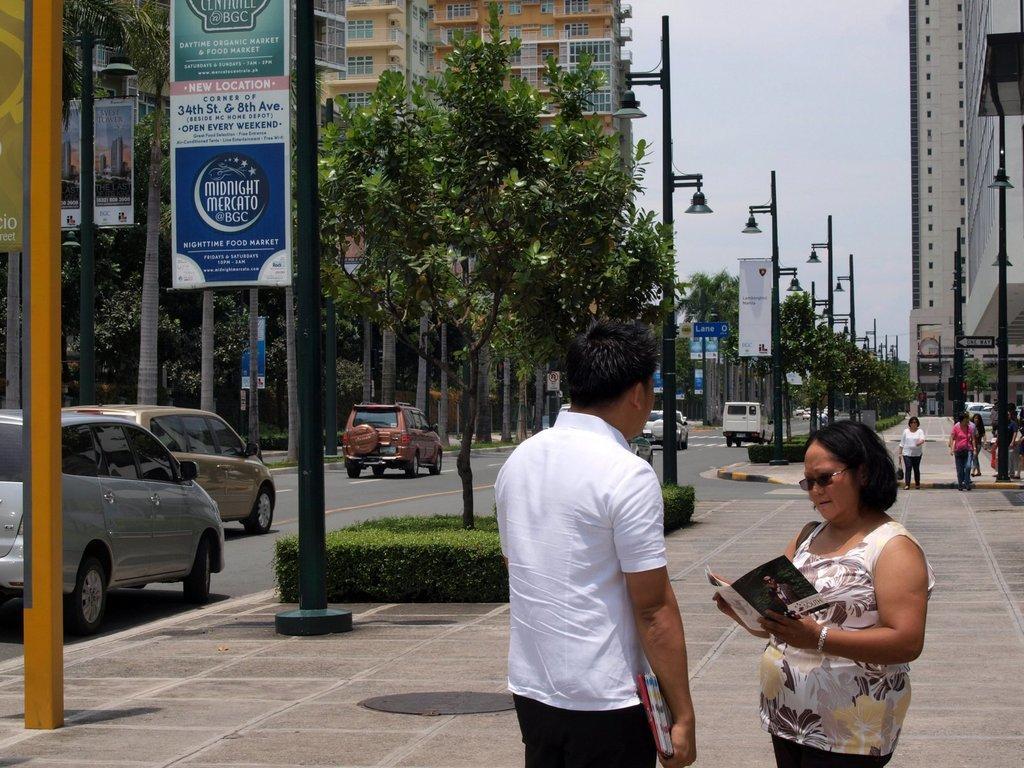In one or two sentences, can you explain what this image depicts? In the picture I can see people on the ground. In the background I can see trees, buildings, street lights and vehicles on the road. In the background I can see poles which has boards attached to them and the sky. 